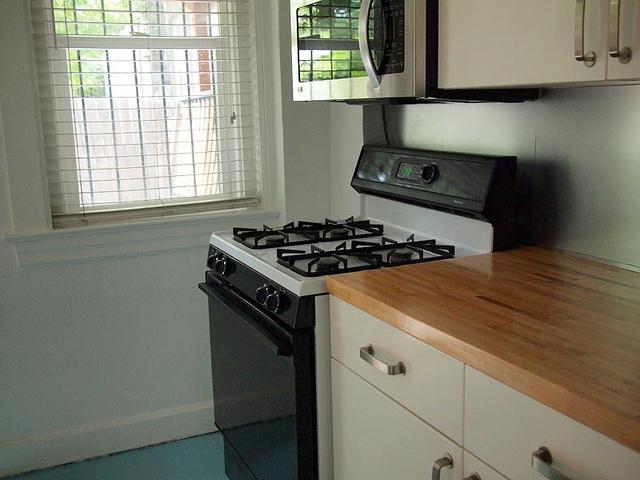Where is the kitchen window?
Be succinct. Next to stove. Is there a fireplace?
Be succinct. No. What is the countertop made of?
Keep it brief. Wood. What powers the stove top?
Answer briefly. Gas. Is there a microwave in this photo?
Be succinct. Yes. 